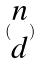<formula> <loc_0><loc_0><loc_500><loc_500>( \begin{matrix} n \\ d \end{matrix} )</formula> 